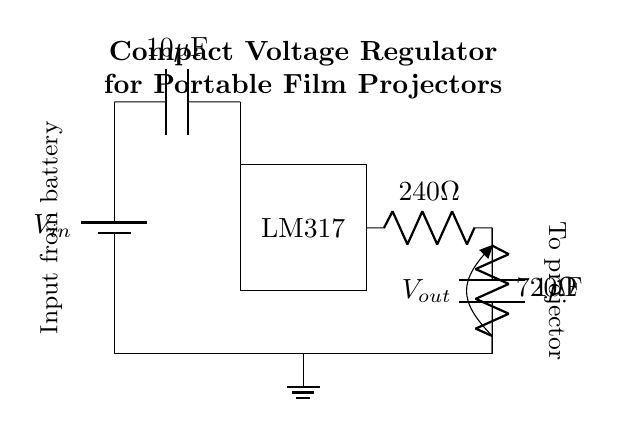What is the input voltage source for this circuit? The circuit diagram shows a battery labeled as V_in connected at the top, which indicates that the circuit uses a battery as the input voltage source.
Answer: V_in What is the value of the first adjustment resistor? The first adjustment resistor in the circuit is labeled as 240 ohms, which can be identified on the right side of the LM317 voltage regulator.
Answer: 240 ohms What type of voltage regulator is used in this circuit? The circuit diagram specifies an LM317 as the voltage regulator, which is a well-known adjustable voltage regulator used to provide a stable output voltage.
Answer: LM317 What is the output capacitor's capacitance value? The output capacitor is labeled as 1 microfarad, and it is shown connected across the output voltage node, which indicates its role in smoothing the output.
Answer: 1 microfarad How do the resistors affect the output voltage? The two resistors, 240 ohms and 720 ohms, form a voltage divider that determines the voltage output from the LM317, affecting how the voltage is regulated for different loads.
Answer: Voltage divider effect What is the purpose of the input capacitor? The input capacitor, which has a capacitance of 10 microfarads, is used to filter voltage spikes and help maintain the stability of the voltage being supplied to the voltage regulator.
Answer: Filtering voltage spikes What is the general application of this circuit? This compact voltage regulator circuit is specifically designed for portable film projectors, ensuring that they receive a consistent and adjustable voltage supply for operation.
Answer: Portable film projectors 